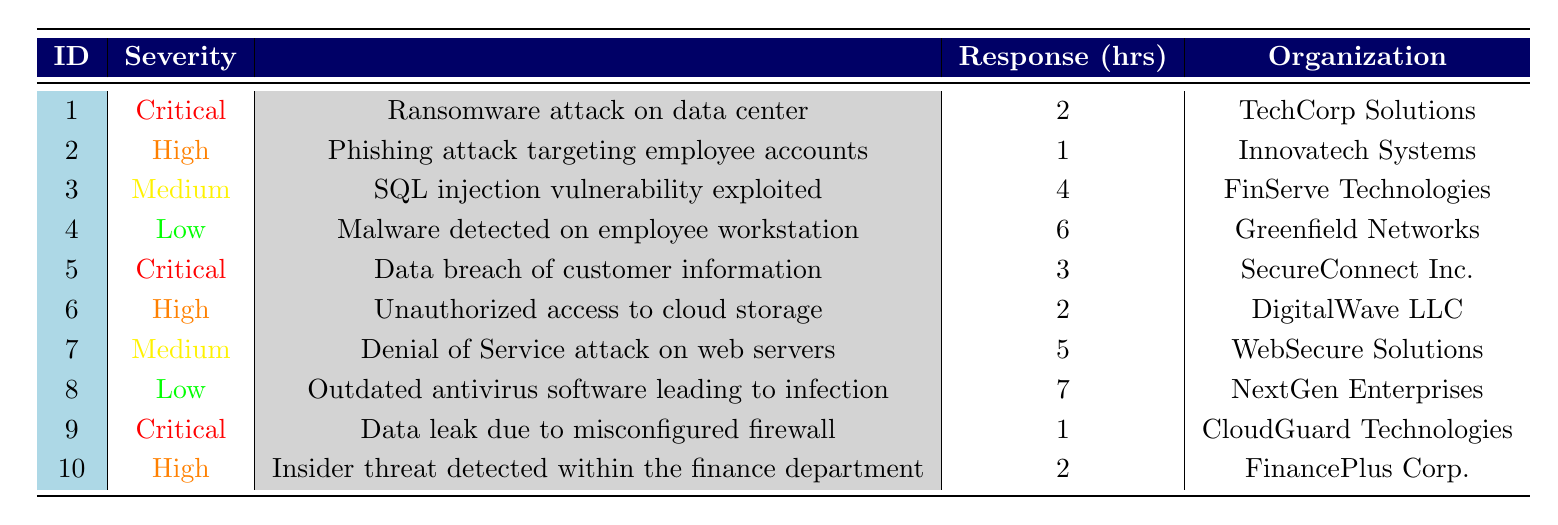What is the response time for the highest severity level incident? The highest severity level is "Critical". There are three such incidents: the ransomware attack with a response time of 2 hours, the data breach with 3 hours, and the data leak with 1 hour. The minimum response time among these is 1 hour.
Answer: 1 hour Which organization experienced a medium severity incident with the longest response time? Among the medium severity incidents, there are two: SQL injection with 4 hours and Denial of Service attack with 5 hours. The latter has the longest response time.
Answer: WebSecure Solutions How many incidents had a response time of less than 3 hours? The incidents with a response time of less than 3 hours are the phishing attack (1 hour), critical ransomware attack (2 hours), unauthorized access (2 hours), and critical data leak (1 hour). Counting these, there are four such incidents.
Answer: 4 Are there any low severity incidents reported? Yes, looking at the table, there are two low severity incidents: malware detection and outdated antivirus software, confirming the existence of low severity incidents.
Answer: Yes What is the average response time of all the incidents? First sum the response times: 2 + 1 + 4 + 6 + 3 + 2 + 5 + 7 + 1 + 2 = 33. There are 10 incidents, so the average response time is 33 divided by 10, which equals 3.3 hours.
Answer: 3.3 hours Which severity level had the highest number of incidents? There are three critical, three high, two medium, and two low severity incidents. The critical and high severity levels are tied with the highest number, each having three incidents.
Answer: Critical and High How many incident descriptions mention data breaches? The incidents mentioning data breaches are the ransomware attack, data breach of customer information, and data leak due to misconfigured firewall. Therefore, there are three incidents that mention data breaches.
Answer: 3 What is the response time for the highest medium severity incident? The medium severity incidents are SQL injection with 4 hours and Denial of Service attack with 5 hours. The latter is the highest response time for medium severity.
Answer: 5 hours 